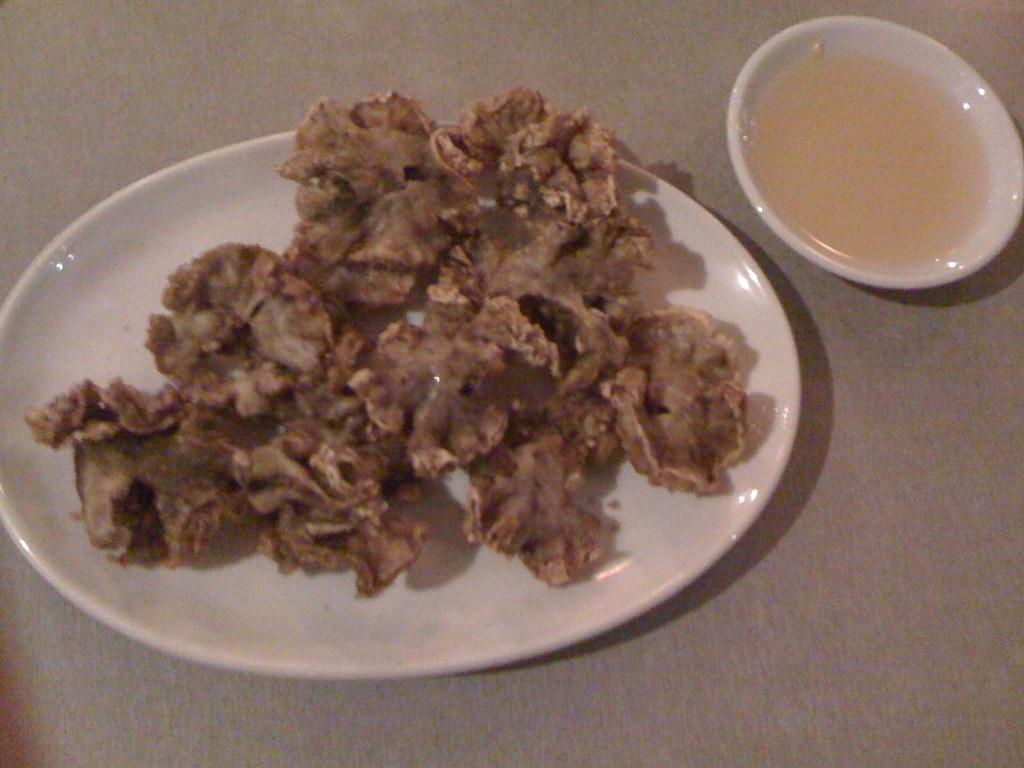What is on the plate that is visible in the image? There is a plate with fried items in the image. What accompanies the fried items on the plate? There is a small bowl with sauce in the image. What type of nail is being used to hang the scarf in the image? There is no nail or scarf present in the image; it only features a plate with fried items and a small bowl with sauce. 